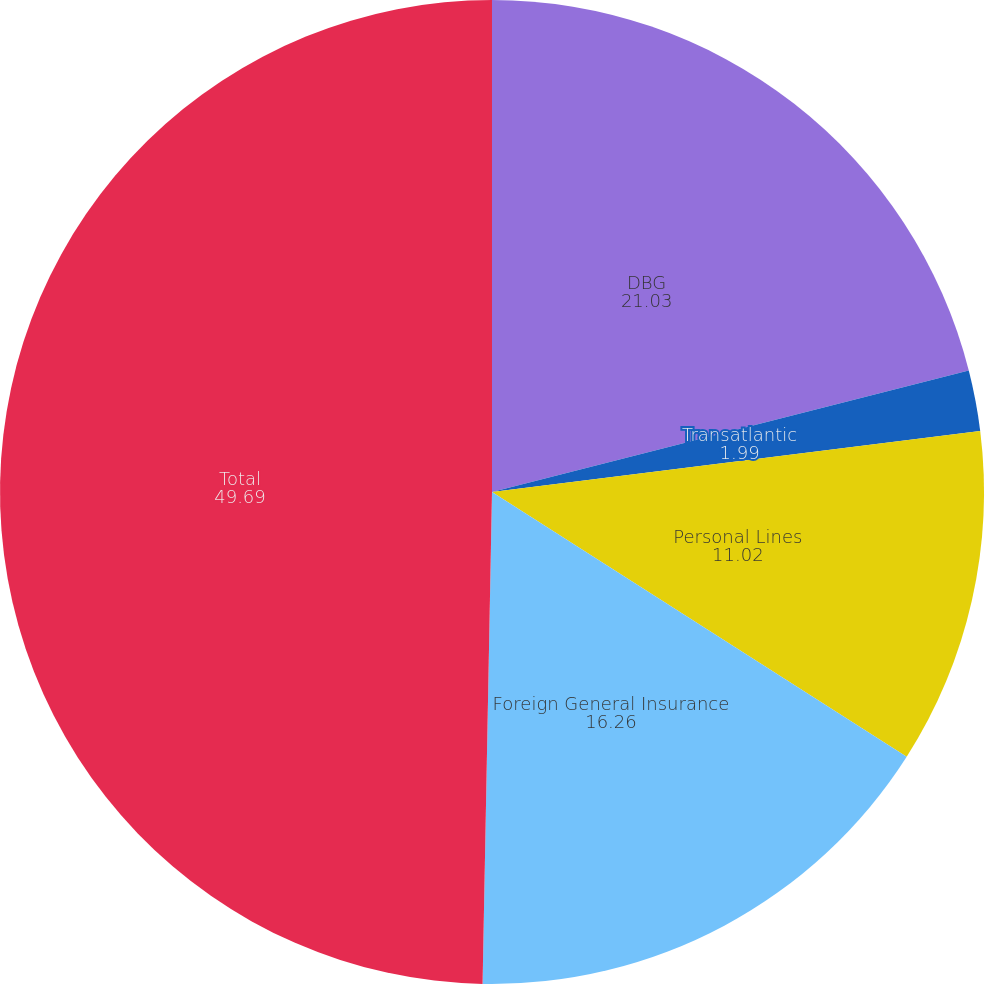Convert chart to OTSL. <chart><loc_0><loc_0><loc_500><loc_500><pie_chart><fcel>DBG<fcel>Transatlantic<fcel>Personal Lines<fcel>Foreign General Insurance<fcel>Total<nl><fcel>21.03%<fcel>1.99%<fcel>11.02%<fcel>16.26%<fcel>49.69%<nl></chart> 